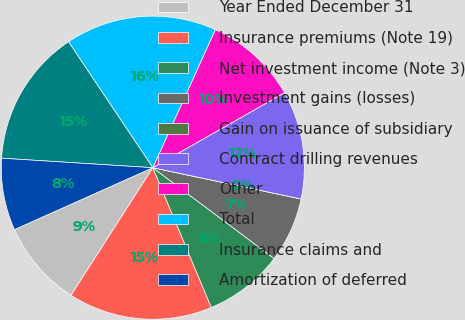<chart> <loc_0><loc_0><loc_500><loc_500><pie_chart><fcel>Year Ended December 31<fcel>Insurance premiums (Note 19)<fcel>Net investment income (Note 3)<fcel>Investment gains (losses)<fcel>Gain on issuance of subsidiary<fcel>Contract drilling revenues<fcel>Other<fcel>Total<fcel>Insurance claims and<fcel>Amortization of deferred<nl><fcel>9.23%<fcel>15.38%<fcel>8.46%<fcel>6.92%<fcel>0.0%<fcel>11.54%<fcel>10.0%<fcel>16.15%<fcel>14.61%<fcel>7.69%<nl></chart> 